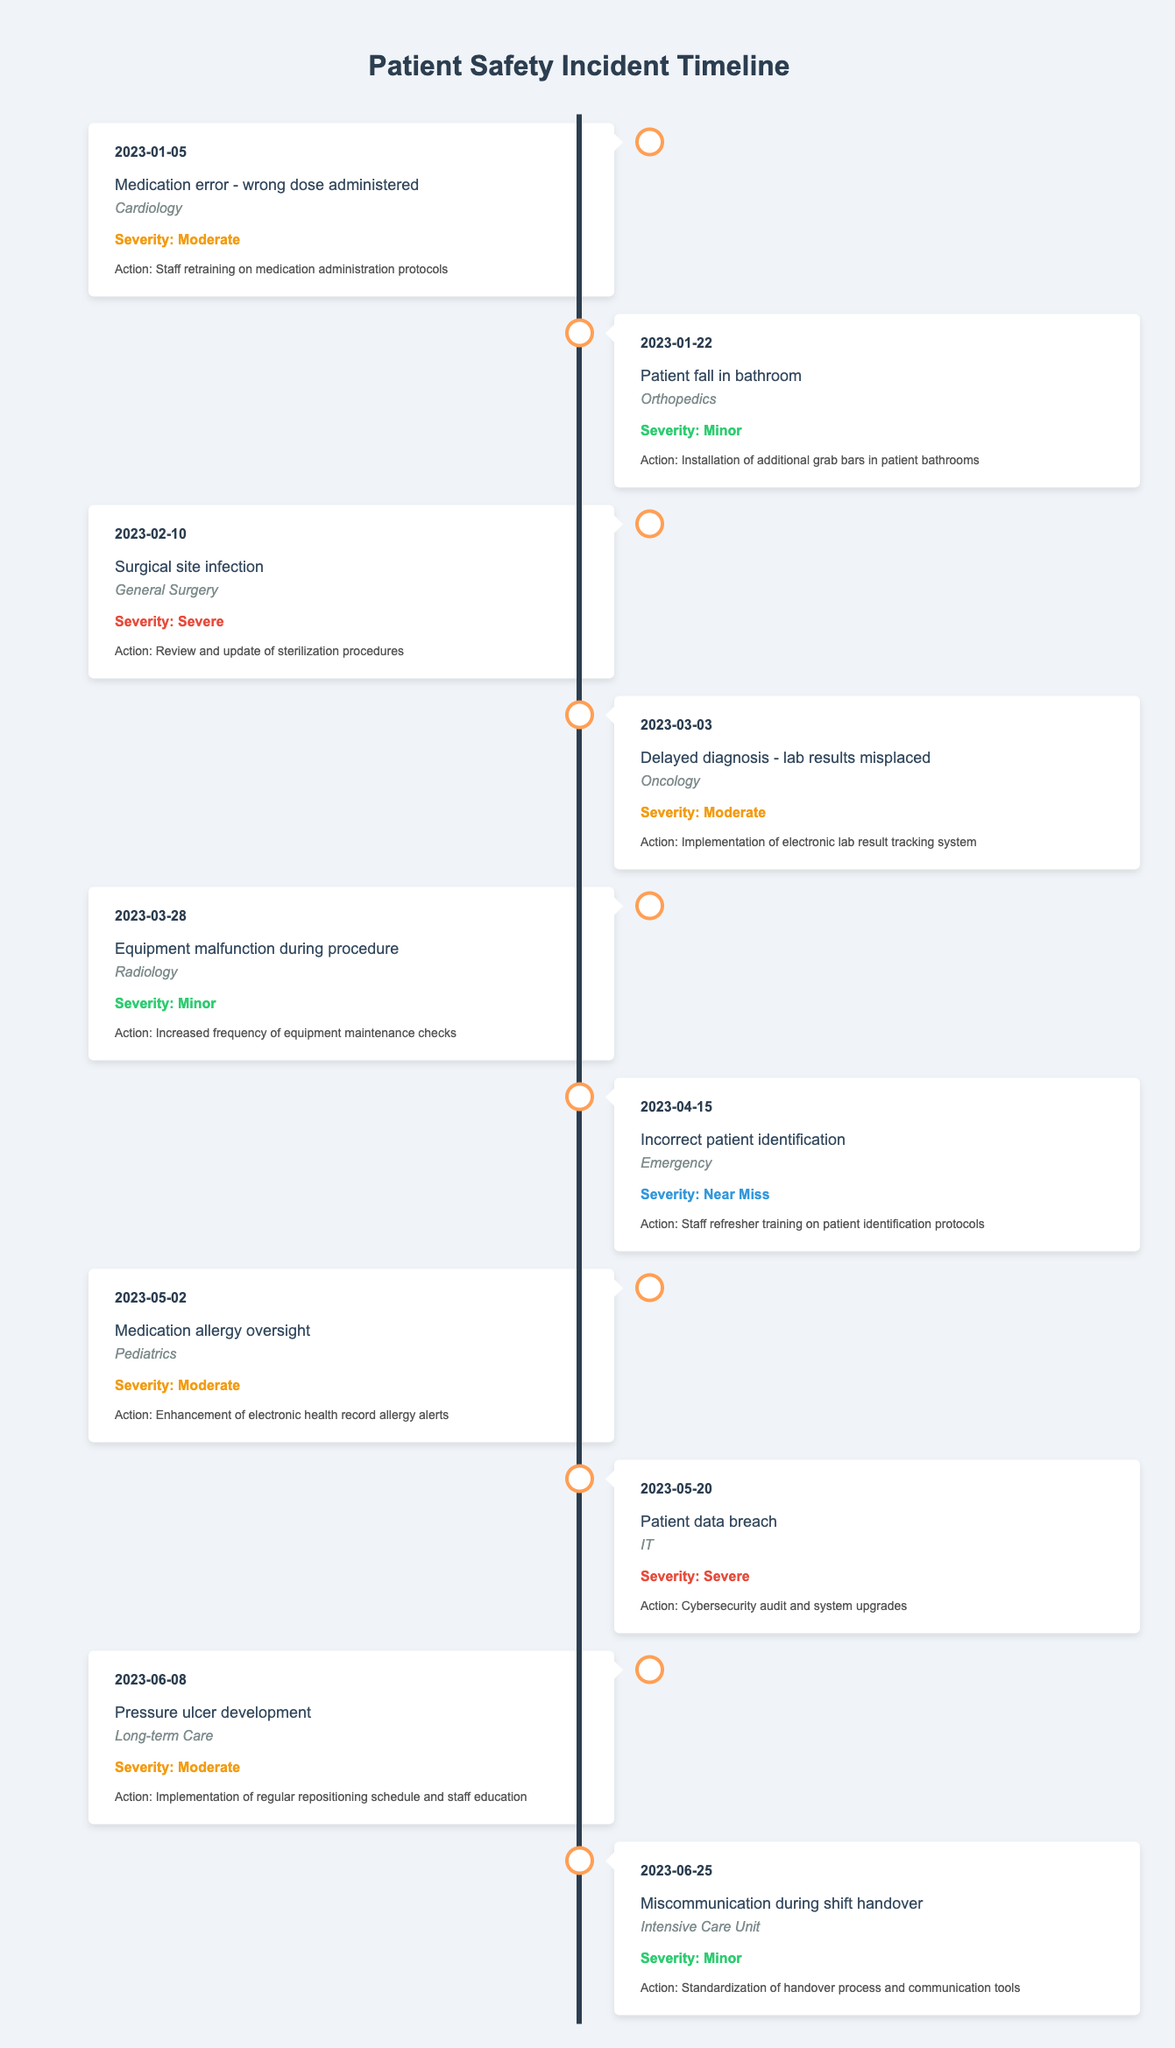What was the most severe incident reported in the timeline? By reviewing the "severity" column, we can identify the incident "Surgical site infection" reported on 2023-02-10 under the "General Surgery" department as the most severe incident.
Answer: Surgical site infection How many incidents were classified as minor? We can check the "severity" column for incidents labeled as "Minor." There are 3 incidents: one on 2023-01-22 (Patient fall in bathroom), one on 2023-03-28 (Equipment malfunction during procedure), and one on 2023-06-25 (Miscommunication during shift handover).
Answer: 3 Did any incident occur in the Pediatrics department? Checking the timeline, we find an incident in the Pediatrics department on 2023-05-02 related to "Medication allergy oversight." Therefore, the answer is true.
Answer: Yes What action was taken to prevent future medication errors? From the entry on 2023-01-05, regarding the "Medication error - wrong dose administered," the action taken was "Staff retraining on medication administration protocols."
Answer: Staff retraining on medication administration protocols On which date did the last incident occur? We look at the timeline data and find that the last incident reported occurred on 2023-06-25 regarding "Miscommunication during shift handover" in the Intensive Care Unit.
Answer: 2023-06-25 How many incidents were related to technology or equipment? Evaluating the incidents, we see that two are related to technology or equipment: "Patient data breach" on 2023-05-20 (IT) and "Equipment malfunction during procedure" on 2023-03-28 (Radiology). Thus, there are 2 incidents.
Answer: 2 Which department had the highest severity incident and what was it? Analyzing the severity of incidents, the highest severity was "Severe," reported twice: on 2023-02-10 (Surgical site infection) and 2023-05-20 (Patient data breach). Both incidents were reported in General Surgery and IT departments, respectively.
Answer: Severe, Surgical site infection and Patient data breach What percentage of the incidents were categorized as "Moderate"? There are 10 incidents total, with 4 labeled as "Moderate" (dates: 2023-01-05, 2023-03-03, 2023-05-02, and 2023-06-08). The percentage of moderate incidents is (4/10)*100 = 40%.
Answer: 40% 